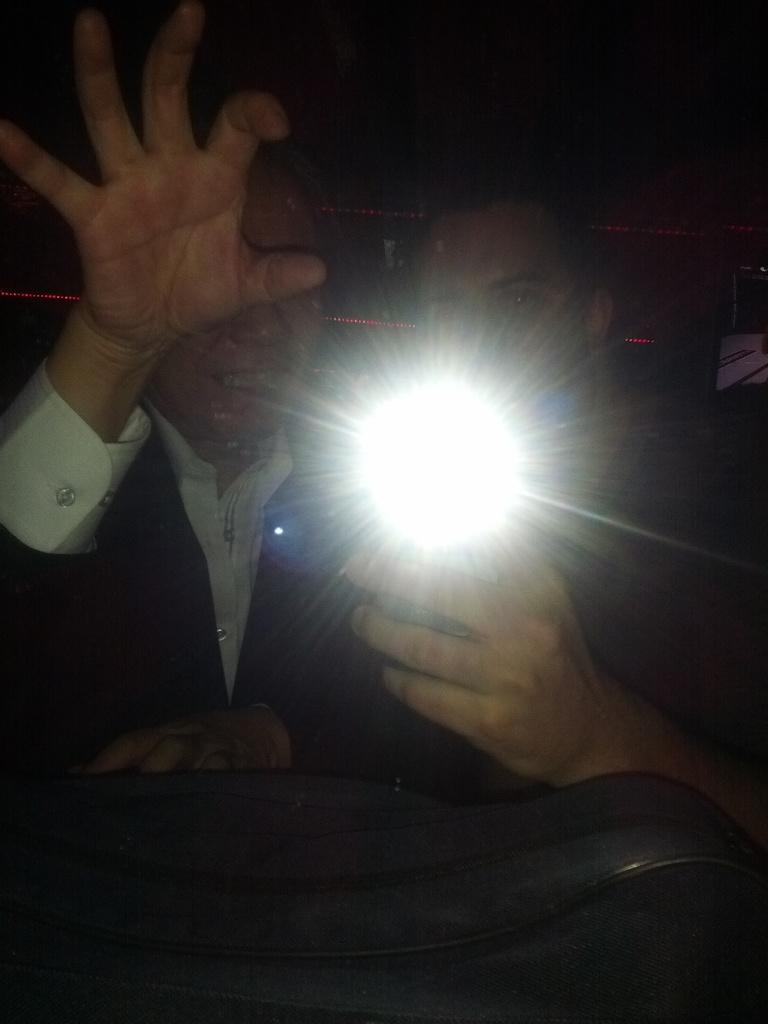How would you summarize this image in a sentence or two? In this image, there are two people. The person on the right side is holding a light. At the bottom of the image, I can see an object. The background looks dark. 